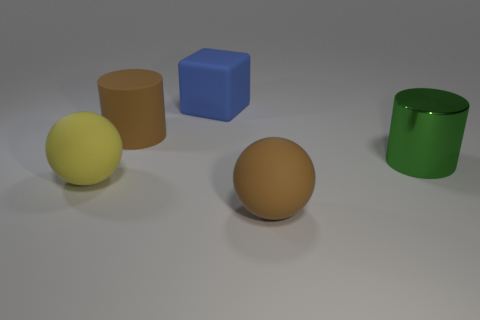Is the material of the big cube the same as the sphere behind the large brown sphere? yes 